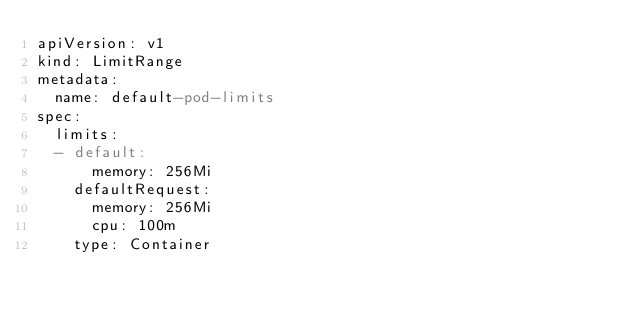Convert code to text. <code><loc_0><loc_0><loc_500><loc_500><_YAML_>apiVersion: v1
kind: LimitRange
metadata:
  name: default-pod-limits
spec:
  limits:
  - default:
      memory: 256Mi
    defaultRequest:
      memory: 256Mi
      cpu: 100m
    type: Container
</code> 